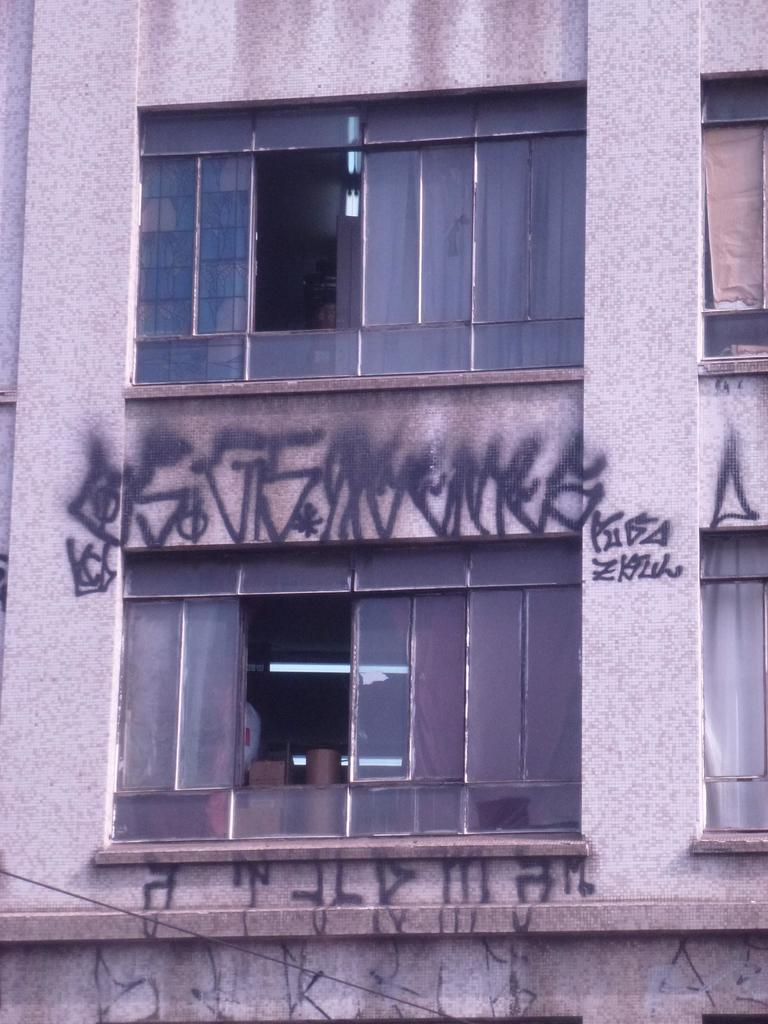What is the main subject of the image? The main subject of the image is a building. What features can be observed on the building? The building has windows and there is writing on the building. How many cakes are displayed on the windows of the building in the image? There are no cakes present on the windows of the building in the image. What type of comb is used to style the love in the image? There is no love or comb present in the image; it features a building with windows and writing. 